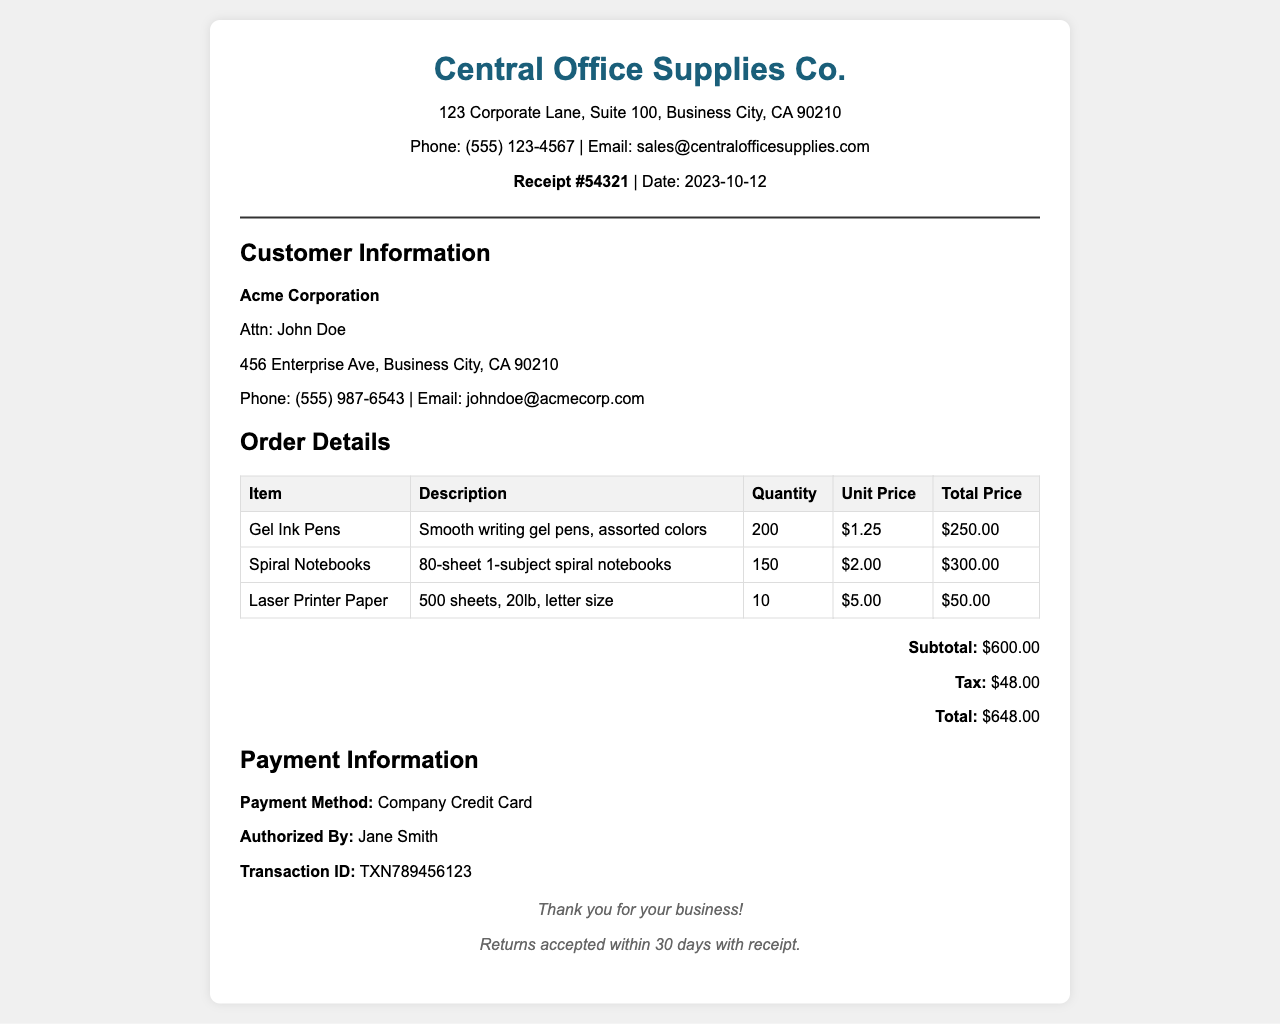What is the receipt number? The receipt number is listed at the top of the document, specifically as #54321.
Answer: 54321 What is the date of the purchase? The date of the purchase is indicated on the receipt, shown as 2023-10-12.
Answer: 2023-10-12 Who is the customer? The customer's name is mentioned in the customer information section as Acme Corporation.
Answer: Acme Corporation What is the total amount of the purchase? The total amount is summed up in the summary section, which displays $648.00.
Answer: $648.00 How many gel ink pens were ordered? The quantity of gel ink pens ordered is provided in the order details as 200.
Answer: 200 What is the unit price of the spiral notebooks? The unit price for the spiral notebooks is specified in the order details as $2.00.
Answer: $2.00 What method of payment was used? The method of payment is found in the payment information section, which states Company Credit Card.
Answer: Company Credit Card Who authorized the payment? The authorized person for the payment is noted in the document as Jane Smith.
Answer: Jane Smith How many sheets of printer paper are included in the order? The order details specify 500 sheets of printer paper were ordered.
Answer: 500 sheets 